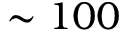<formula> <loc_0><loc_0><loc_500><loc_500>\sim 1 0 0</formula> 